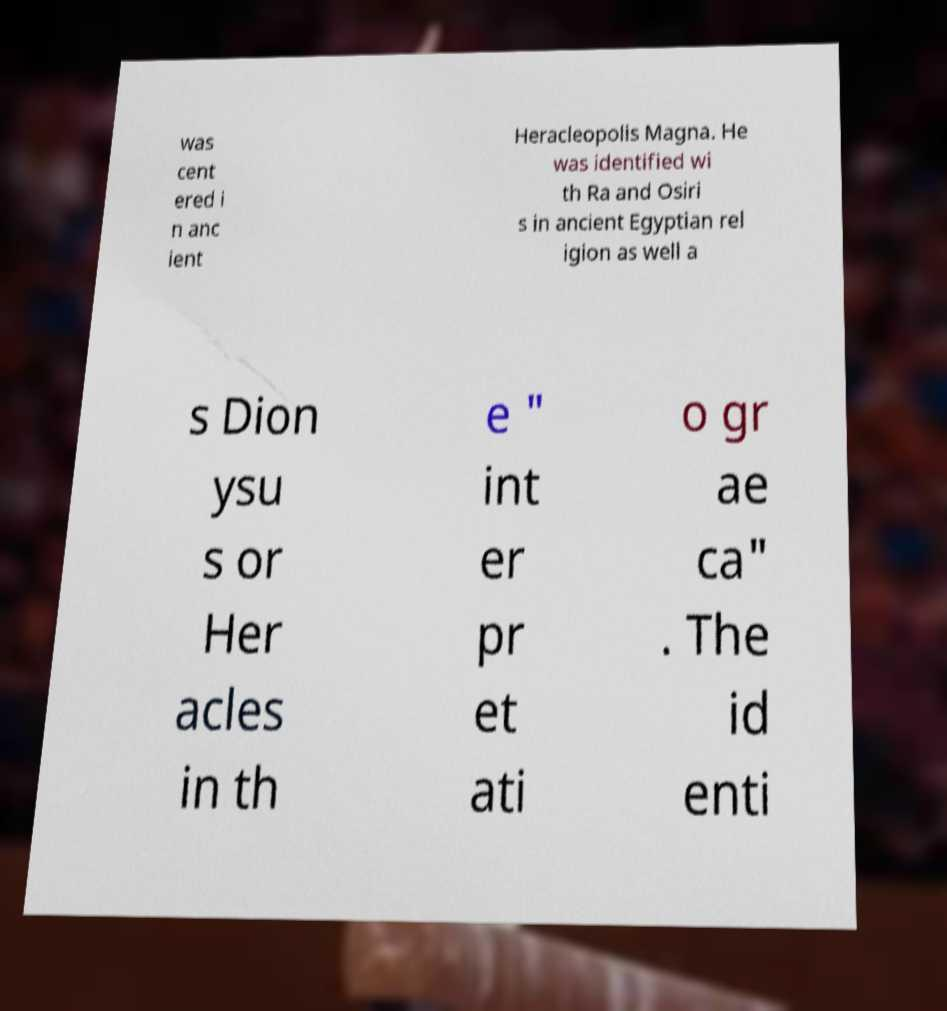Can you read and provide the text displayed in the image?This photo seems to have some interesting text. Can you extract and type it out for me? was cent ered i n anc ient Heracleopolis Magna. He was identified wi th Ra and Osiri s in ancient Egyptian rel igion as well a s Dion ysu s or Her acles in th e " int er pr et ati o gr ae ca" . The id enti 